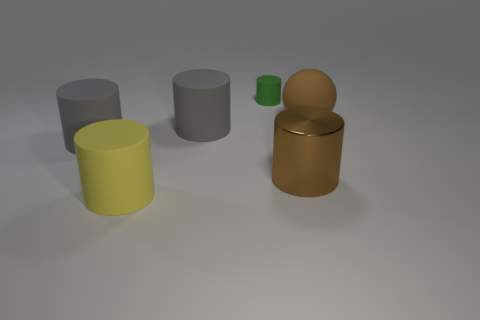Subtract all brown cylinders. How many cylinders are left? 4 Subtract all green cylinders. How many cylinders are left? 4 Subtract all cyan cylinders. Subtract all red spheres. How many cylinders are left? 5 Add 3 big yellow rubber blocks. How many objects exist? 9 Subtract all balls. How many objects are left? 5 Subtract 0 purple cylinders. How many objects are left? 6 Subtract all gray cylinders. Subtract all big yellow matte things. How many objects are left? 3 Add 5 matte cylinders. How many matte cylinders are left? 9 Add 4 big cyan cylinders. How many big cyan cylinders exist? 4 